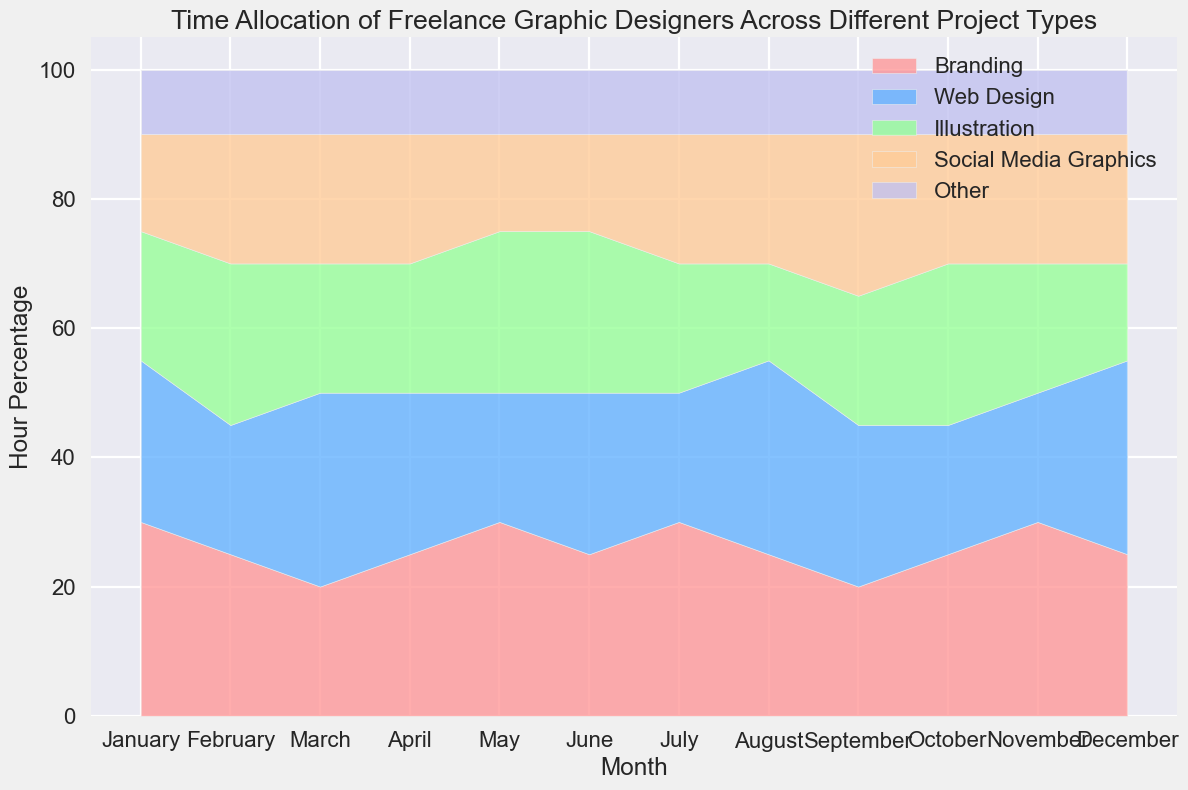What is the only month where "Illustration" occupies the highest percentage of time? To determine which month has the highest percentage allocated to "Illustration," we observe the visual stack for each month. March has "Illustration" as one of the tallest segments, indicating the highest allocation.
Answer: March Which project type consistently occupies a smaller portion compared to other types across all months? Look for the segment that consistently has a smaller height across all months. The "Other" category always has the smallest portion of the stack.
Answer: Other In which month is the time allocation for "Branding" and "Web Design" equal? To find the month where "Branding" and "Web Design" categories are equal, compare the heights of these segments across the months. They appear equal in April and June.
Answer: April and June Which month has the lowest total percentage allocated to "Web Design" and "Illustration"? Add the percentages of "Web Design" and "Illustration" for each month and identify the month with the lowest total. For July, it's 20% + 20% = 40%.
Answer: July What is the average percentage of time allocated for "Social Media Graphics" across the first quarter (January to March)? Add the percentages for "Social Media Graphics" from January, February, and March, then divide the total by three. (15 + 20 + 20) / 3 = 18.33.
Answer: 18.33 During which month does "Web Design" have the highest percentage allocation? Look for the month where the "Web Design" segment is the tallest. It is highest in March and August.
Answer: March and August Which category sees a dip in allocation in May compared to April? Compare the heights of segments for each category from April to May. "Web Design" allocation dips from 25% in April to 20% in May.
Answer: Web Design In August, which category has the smallest percentage allocation? Observe the segment heights for each category in August. "Illustration" has the smallest segment, which is 15%.
Answer: Illustration What is the average monthly allocation for "Other" across the entire year? Sum the monthly allocations for "Other" and divide by 12. (10 * 12 months) / 12 = 10.
Answer: 10 Which month shows a balanced allocation (similar percentages) among all categories? Identify the month where the segment heights are more evenly distributed. February has 25%, 20%, 25%, 20%, and 10%.
Answer: February 